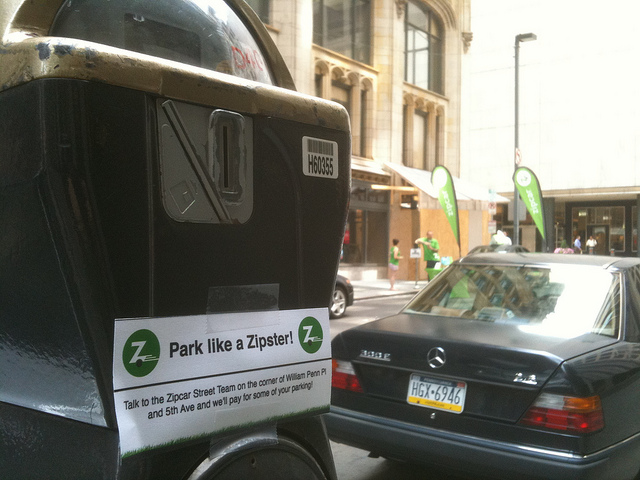Please extract the text content from this image. H60355 Zipster a like Park 6946 HGX. you penn some pay well and 5th and the on Team Street Zipcar 10 Talk Z Z 